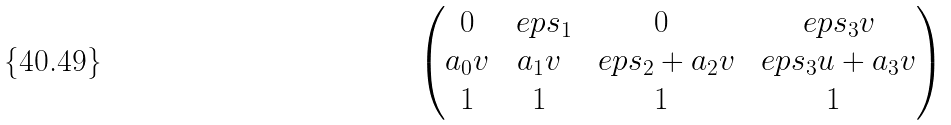Convert formula to latex. <formula><loc_0><loc_0><loc_500><loc_500>\begin{pmatrix} 0 & \ e p s _ { 1 } & 0 & \ e p s _ { 3 } v \\ a _ { 0 } v & a _ { 1 } v & \ e p s _ { 2 } + a _ { 2 } v & \ e p s _ { 3 } u + a _ { 3 } v \\ 1 & 1 & 1 & 1 \end{pmatrix}</formula> 